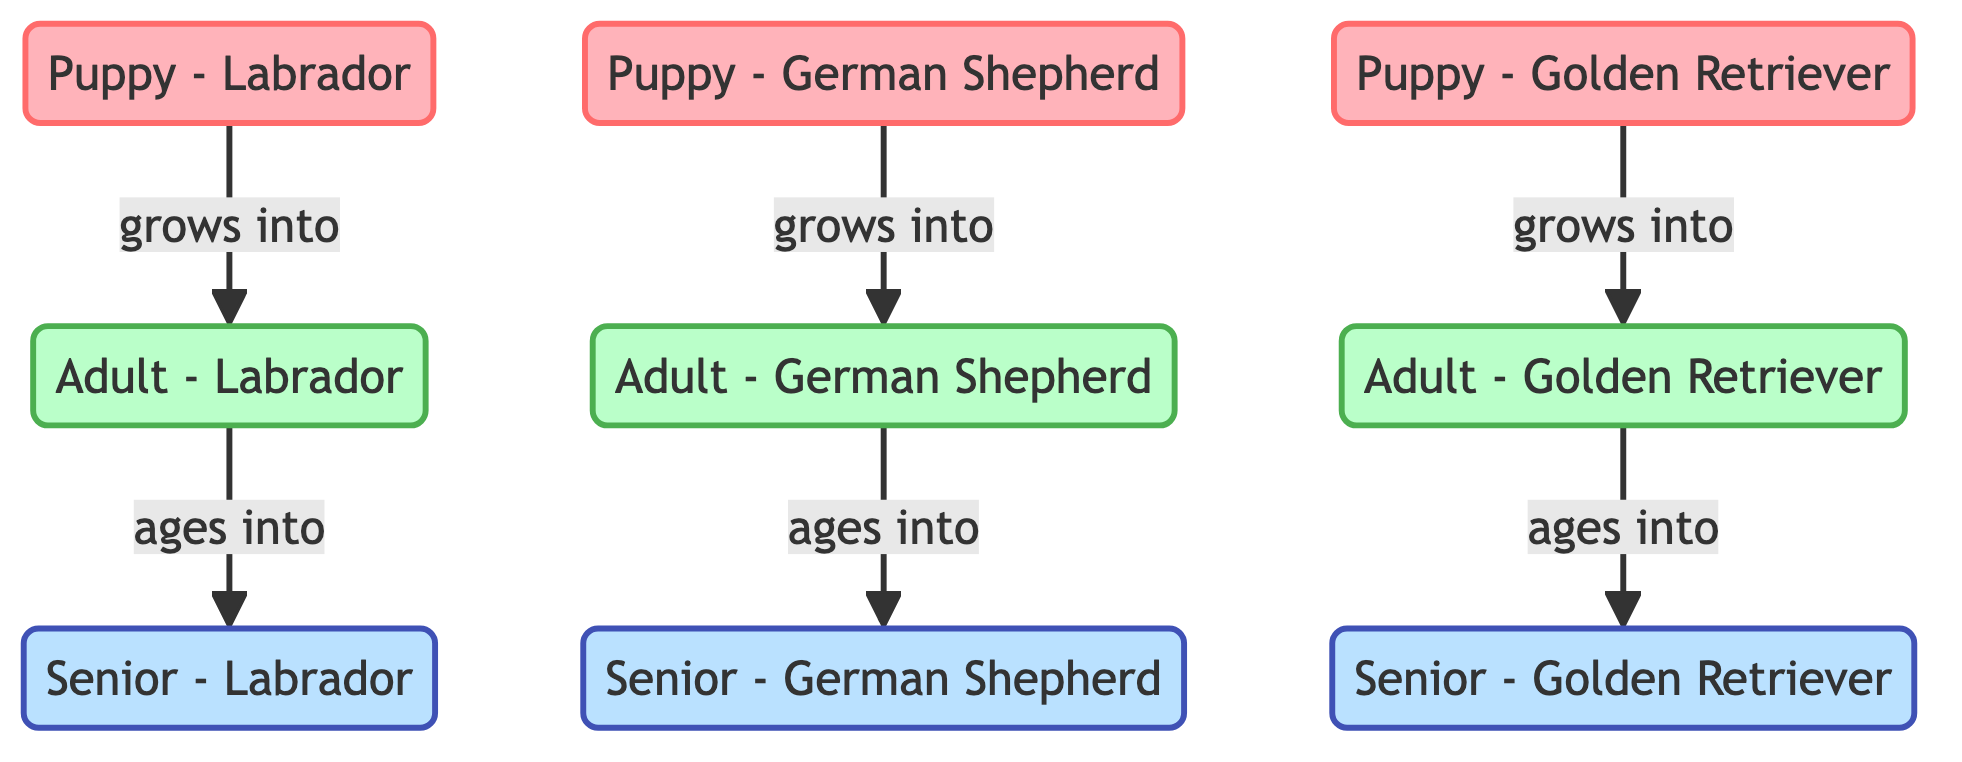What breeds are represented in the "Puppy" stage? The diagram includes three nodes in the "Puppy" stage: Labrador, German Shepherd, and Golden Retriever.
Answer: Labrador, German Shepherd, Golden Retriever How many "Senior" stage nodes are in the diagram? The diagram shows three nodes in the "Senior" stage: Senior - Labrador, Senior - German Shepherd, and Senior - Golden Retriever.
Answer: 3 Which breed do "Puppy - Golden Retriever" grow into? The diagram indicates that "Puppy - Golden Retriever" grows into "Adult - Golden Retriever."
Answer: Adult - Golden Retriever What is the relationship between "Adult - Labrador" and "Senior - Labrador"? The relationship is defined in the diagram as "Adult - Labrador" ages into "Senior - Labrador."
Answer: ages into How many edges represent the aging process from Adult to Senior in the diagram? There are three edges showing the transition from Adult to Senior for each breed: Labrador, German Shepherd, and Golden Retriever.
Answer: 3 Which stage does "Senior - German Shepherd" represent? This node represents the final life stage of the German Shepherd breed, indicating the aging process from adult to senior.
Answer: Senior What is the total number of nodes in the diagram? The diagram consists of nine nodes representing different stages and breeds.
Answer: 9 What flows from "Puppy - Labrador" to "Adult - Labrador"? The diagram indicates that "Puppy - Labrador" grows into "Adult - Labrador."
Answer: grows into Which breed has the lowest representation in the diagram? All the breeds have an equal representation across the different stages, making them uniformly represented.
Answer: None (equal representation) 